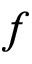Convert formula to latex. <formula><loc_0><loc_0><loc_500><loc_500>f</formula> 